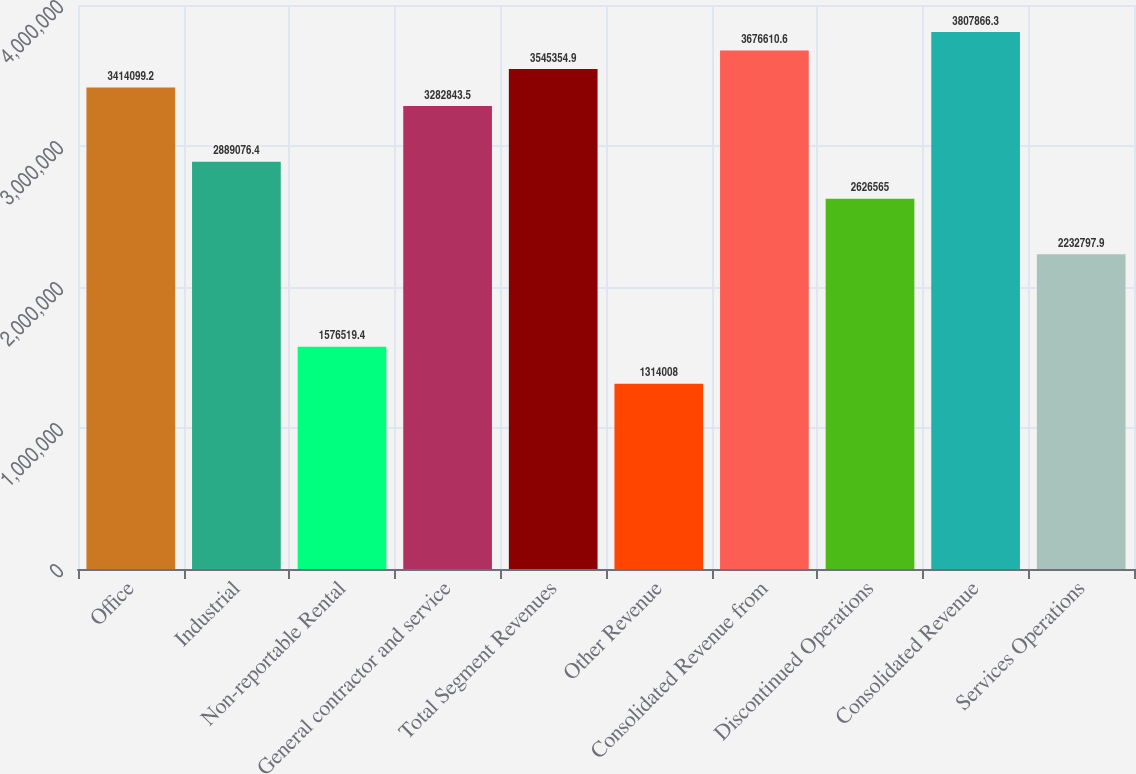Convert chart. <chart><loc_0><loc_0><loc_500><loc_500><bar_chart><fcel>Office<fcel>Industrial<fcel>Non-reportable Rental<fcel>General contractor and service<fcel>Total Segment Revenues<fcel>Other Revenue<fcel>Consolidated Revenue from<fcel>Discontinued Operations<fcel>Consolidated Revenue<fcel>Services Operations<nl><fcel>3.4141e+06<fcel>2.88908e+06<fcel>1.57652e+06<fcel>3.28284e+06<fcel>3.54535e+06<fcel>1.31401e+06<fcel>3.67661e+06<fcel>2.62656e+06<fcel>3.80787e+06<fcel>2.2328e+06<nl></chart> 